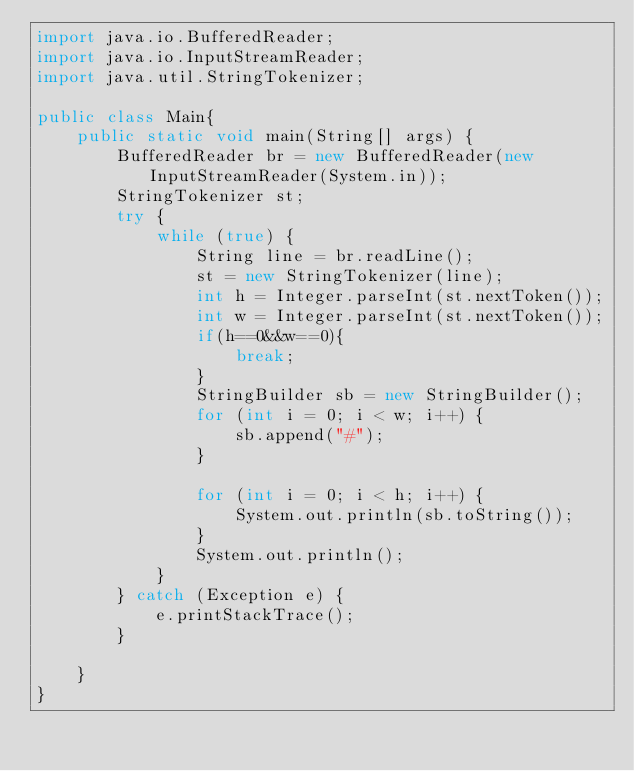Convert code to text. <code><loc_0><loc_0><loc_500><loc_500><_Java_>import java.io.BufferedReader;
import java.io.InputStreamReader;
import java.util.StringTokenizer;

public class Main{
    public static void main(String[] args) {
        BufferedReader br = new BufferedReader(new InputStreamReader(System.in));
        StringTokenizer st;
        try {
            while (true) {
                String line = br.readLine();
                st = new StringTokenizer(line);
                int h = Integer.parseInt(st.nextToken());
                int w = Integer.parseInt(st.nextToken());
                if(h==0&&w==0){
                    break;
                }
                StringBuilder sb = new StringBuilder();
                for (int i = 0; i < w; i++) {
                    sb.append("#");
                }

                for (int i = 0; i < h; i++) {
                    System.out.println(sb.toString());
                }
                System.out.println();
            }
        } catch (Exception e) {
            e.printStackTrace();
        }

    }
}</code> 